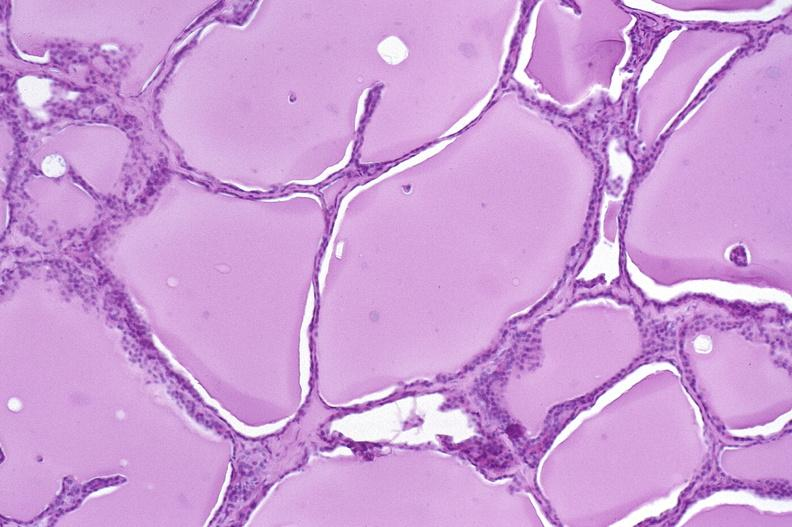does mesentery show thyroid gland, normal?
Answer the question using a single word or phrase. No 